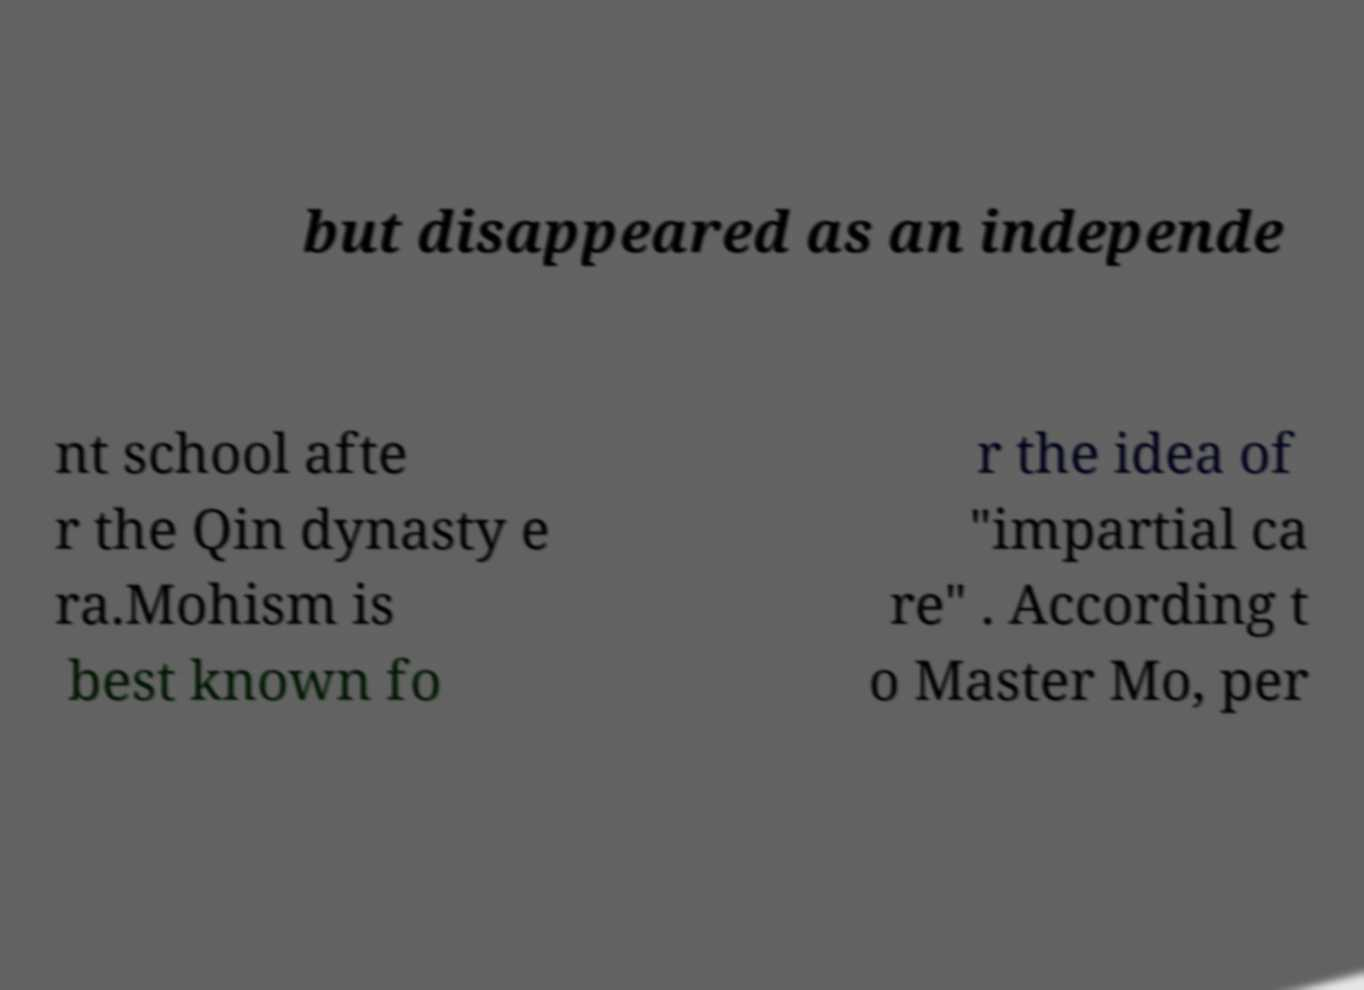Could you extract and type out the text from this image? but disappeared as an independe nt school afte r the Qin dynasty e ra.Mohism is best known fo r the idea of "impartial ca re" . According t o Master Mo, per 